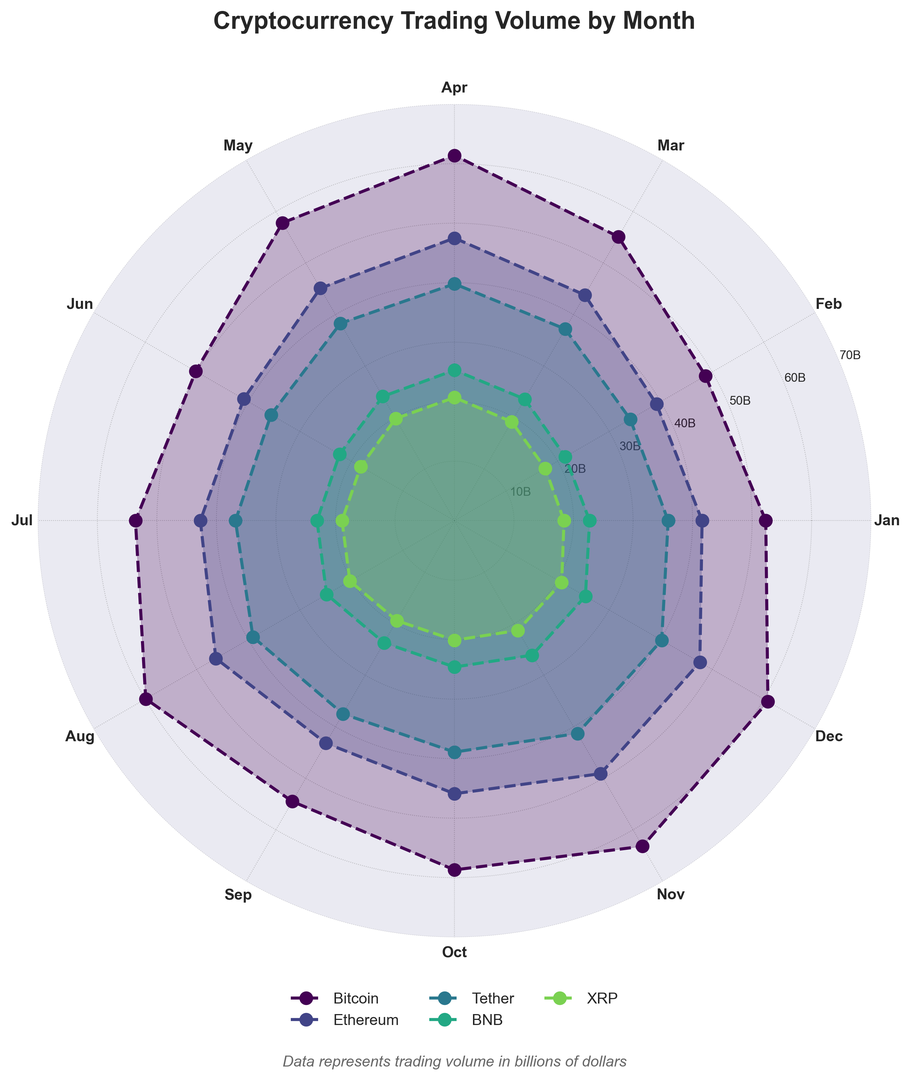Which cryptocurrency had the highest trading volume in October? By looking at the chart, we can see that Bitcoin's line is at the highest point in October compared to other cryptocurrencies.
Answer: Bitcoin Which month had the lowest trading volume for Ethereum? By observing the position of Ethereum's line closest to the center, we see that February has the lowest value.
Answer: February What was the difference in trading volume for Tether between January and December? Tether's January value is 35.9, and the December value is 40.2. The difference is 40.2 - 35.9.
Answer: 4.3 Which cryptocurrency appears to have the most consistent trading volume throughout the year? By analyzing the smoothness and even spacing of the lines, we can see that Tether's trading volume is the most consistent without major peaks or dips.
Answer: Tether During which month did BNB have a trading volume greater than XRP's but less than Ethereum's? By comparing the respective lines, we can observe that in March, BNB's trading volume (23.6) is greater than XRP (19.2) but less than Ethereum (43.8).
Answer: March What is the average trading volume of Bitcoin over the entire year? Summing Bitcoin's monthly volumes (52.3, 48.7, 55.1, 61.4, 57.8, 50.2, 53.6, 59.9, 54.5, 58.7, 63.2, 60.8) gives 676.2. Dividing by 12 gives an average.
Answer: 56.35 Among the five cryptocurrencies, which one shows the largest increase in trading volume from February to March? The largest visible increase from the chart corresponds to Bitcoin, which goes from 48.7 in February to 55.1 in March.
Answer: Bitcoin Which cryptocurrency had the lowest trading volume in the month of July? Observing the July values and the lines closest to the center, XRP has the lowest value.
Answer: XRP 